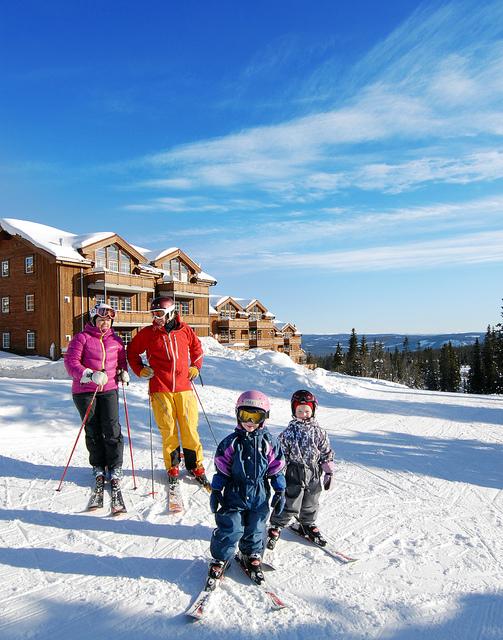What are the people doing?
Give a very brief answer. Skiing. How many children are there?
Quick response, please. 2. Is it snowing?
Quick response, please. No. 